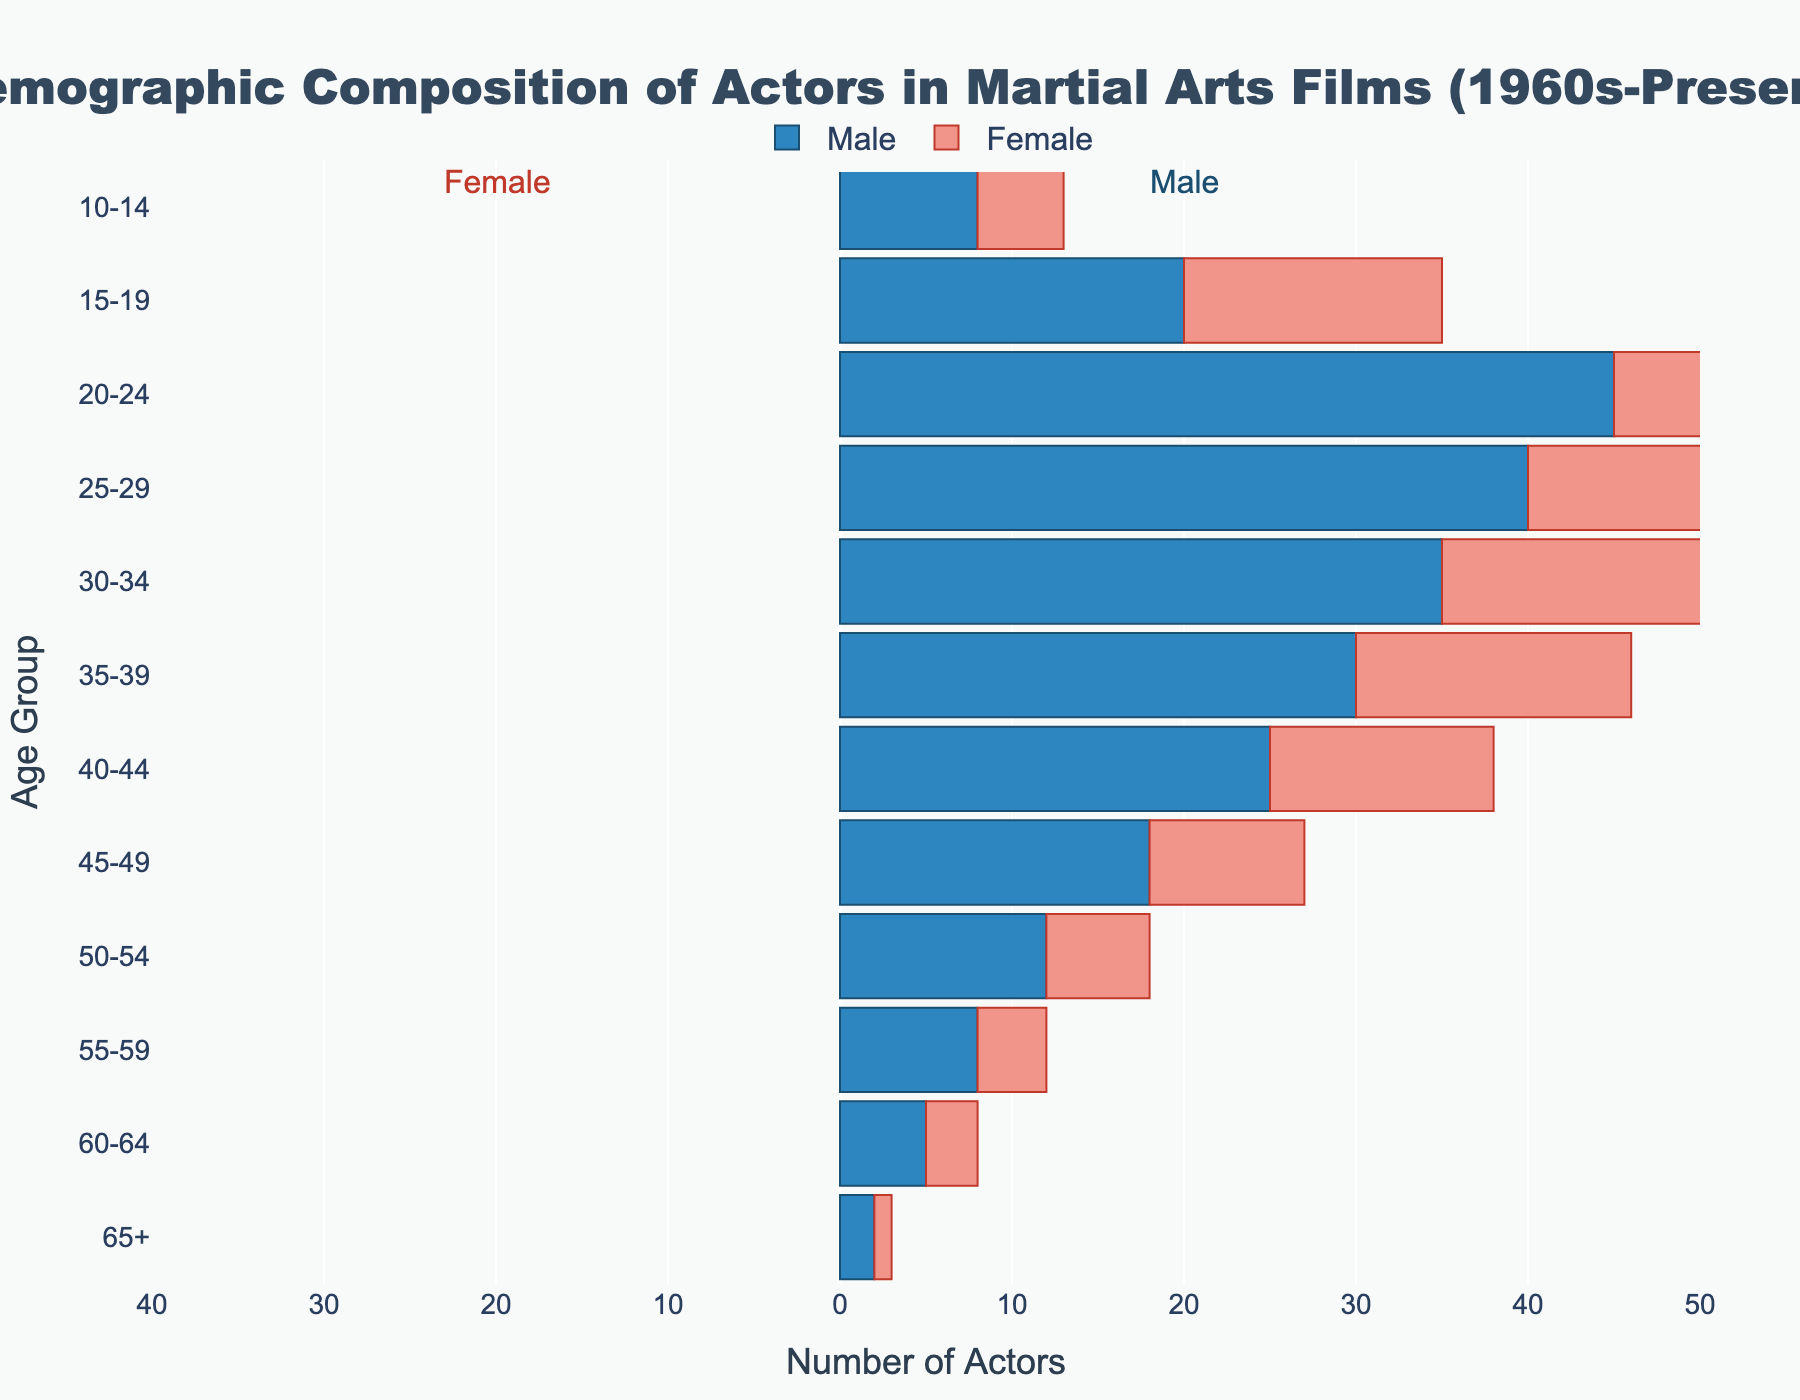What is the age group with the highest number of male actors? Look at the bars on the right side of the pyramid representing male actors. The age group with the longest bar is '20-24'.
Answer: 20-24 In which age group do female actors see the highest representation? Examine the bars on the left side of the pyramid for female actors. The age group with the longest bar is '20-24'.
Answer: 20-24 What is the total number of male actors in the age groups '20-24' and '25-29'? Identify the bar lengths for '20-24' and '25-29' for male actors and add them together. 45 (20-24) + 40 (25-29) = 85.
Answer: 85 What is the difference in the number of female actors between the age groups '20-24' and '25-29'? Identify the bar lengths for '20-24' and '25-29' for female actors. Calculate the difference between them: 30 (20-24) - 25 (25-29) = 5.
Answer: 5 Which age group has the smallest number of female actors and what is that number? Look for the shortest bar on the left side of the pyramid for female actors. The smallest bar is in the '65+' with a value of 1.
Answer: 65+, 1 How many more male actors are there than female actors in the '50-54' age group? Determine the number of male and female actors in the '50-54' age group: 12 (male) and 6 (female). Calculate the difference between them: 12 - 6 = 6.
Answer: 6 What is the combined number of actors (both male and female) in the age group '15-19'? Add the number of male and female actors in '15-19': 20 (male) + 15 (female) = 35.
Answer: 35 In which age group is the gender gap (difference between male and female actors) the largest? Calculate the gender gap for each age group and identify the maximum: '20-24' has a gap of 15 (45 males - 30 females).
Answer: 20-24 How does the representation of female actors change as the age groups increase from '10-14' to '65+'? Observe the trend on the left side of the pyramid: the number of female actors decreases steadily from 5 (10-14) to 1 (65+).
Answer: Decreases 